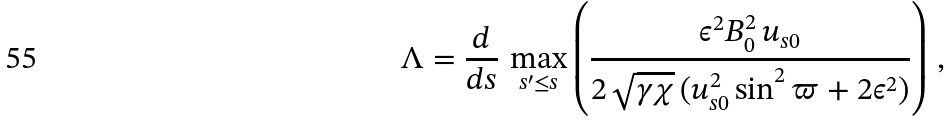Convert formula to latex. <formula><loc_0><loc_0><loc_500><loc_500>\Lambda = \frac { d } { d s } \, \max _ { s ^ { \prime } \leq s } \left ( \frac { \epsilon ^ { 2 } B _ { 0 } ^ { 2 } \, u _ { s 0 } } { 2 \, \sqrt { \gamma \chi } \, ( u _ { s 0 } ^ { 2 } \sin ^ { 2 } \varpi + 2 \epsilon ^ { 2 } ) } \right ) \, ,</formula> 